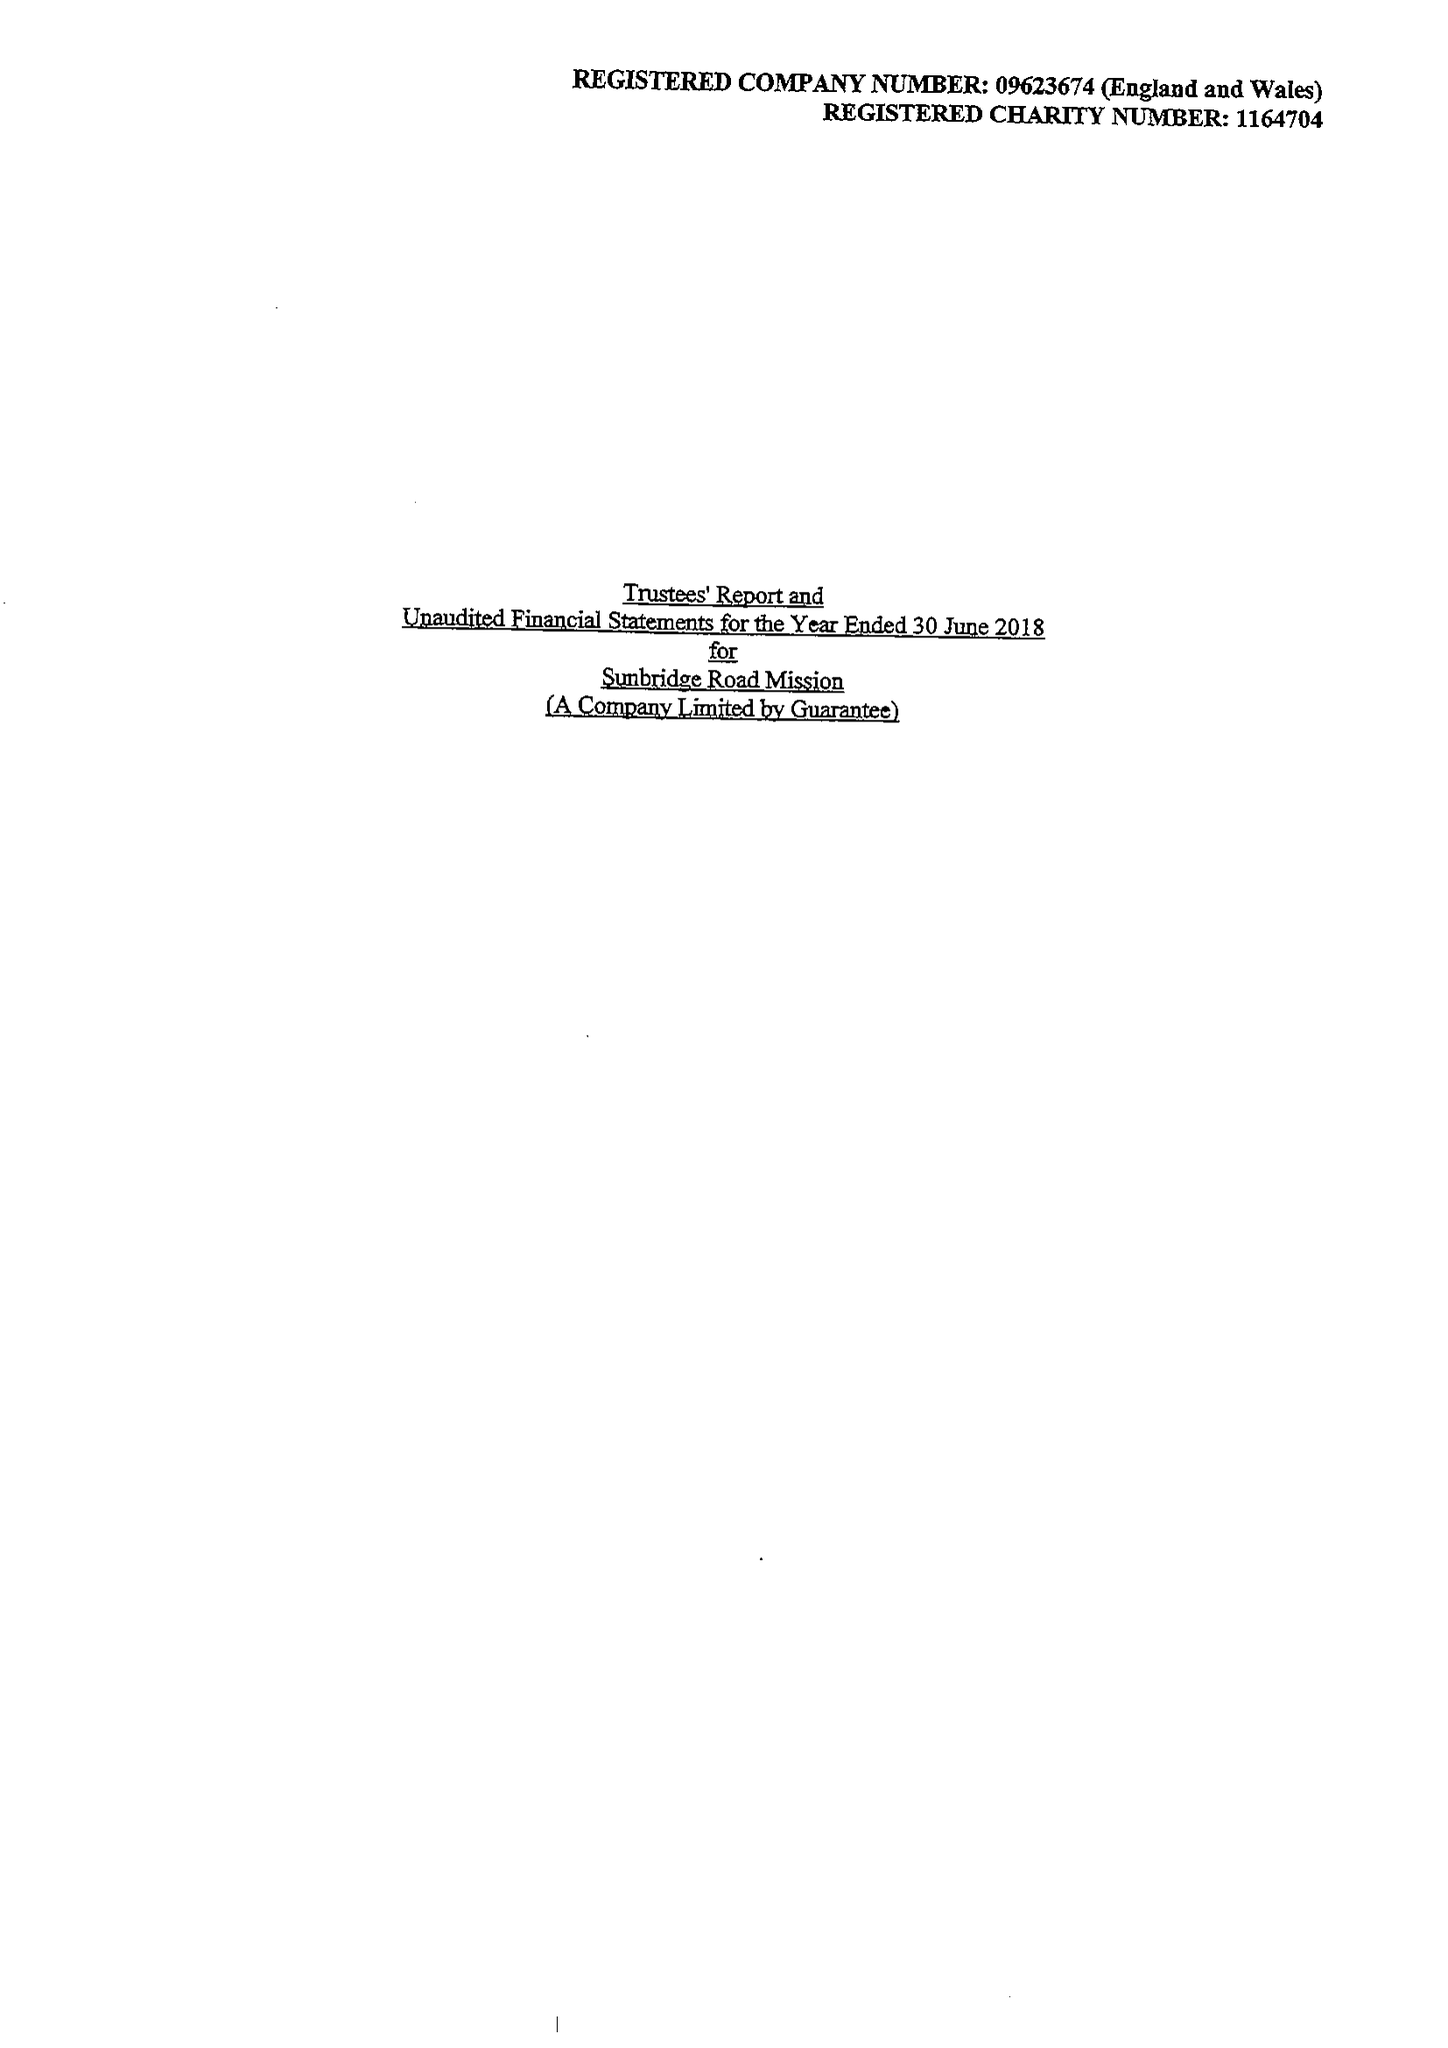What is the value for the address__post_town?
Answer the question using a single word or phrase. BRADFORD 